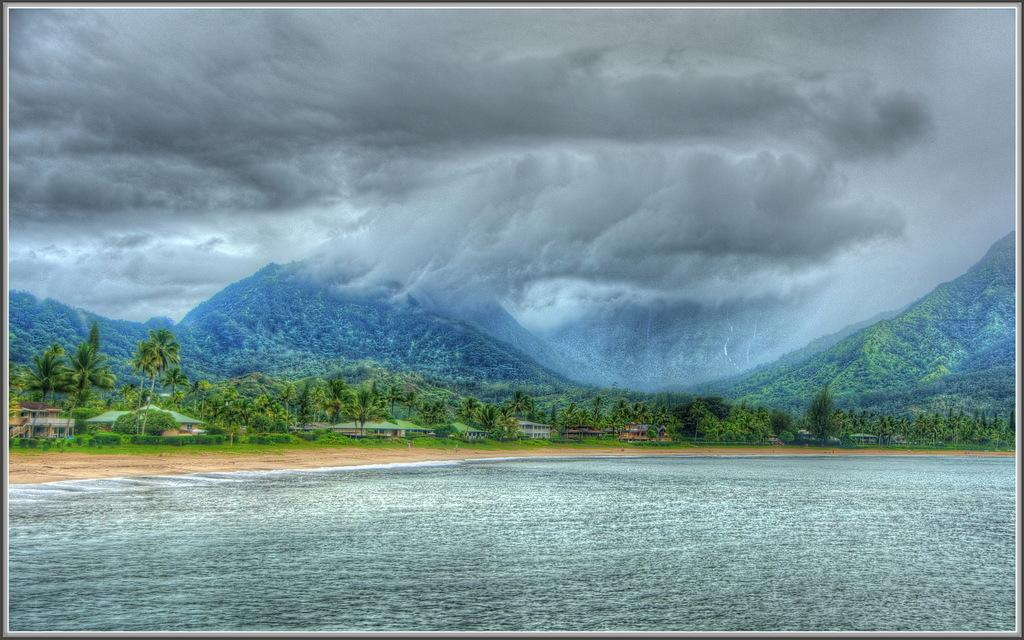What type of natural landform can be seen in the image? There are mountains in the image. What type of vegetation is present in the image? There are trees in the image. What type of man-made structures can be seen in the image? There are buildings in the image. What is visible at the top of the image? The sky is visible at the top of the image. What can be seen in the sky? There are clouds in the sky. What is visible at the bottom of the image? There is water, mud, and grass visible at the bottom of the image. Where is the prison located in the image? There is no prison present in the image. What type of nose can be seen on the trees in the image? Trees do not have noses, so this question is not applicable to the image. 